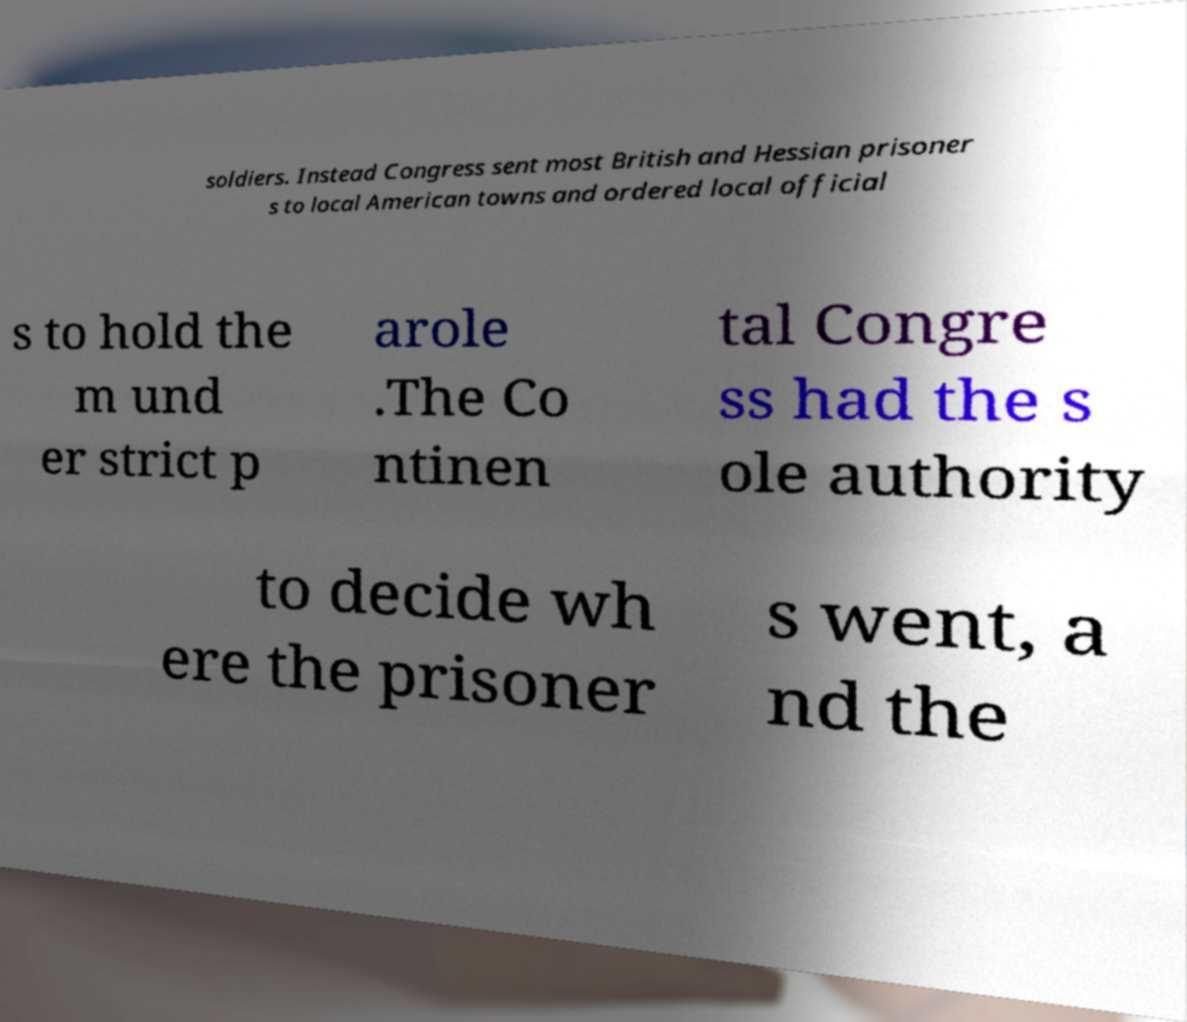For documentation purposes, I need the text within this image transcribed. Could you provide that? soldiers. Instead Congress sent most British and Hessian prisoner s to local American towns and ordered local official s to hold the m und er strict p arole .The Co ntinen tal Congre ss had the s ole authority to decide wh ere the prisoner s went, a nd the 